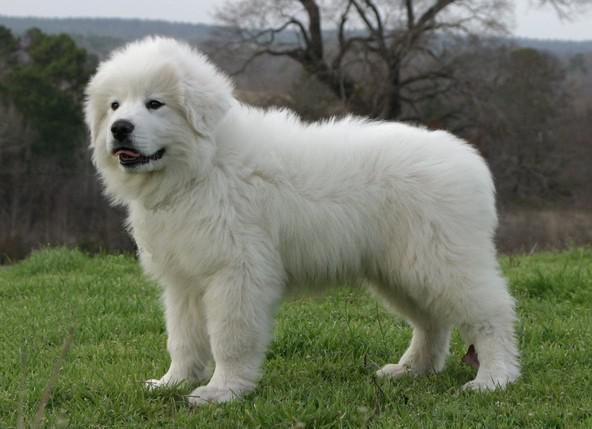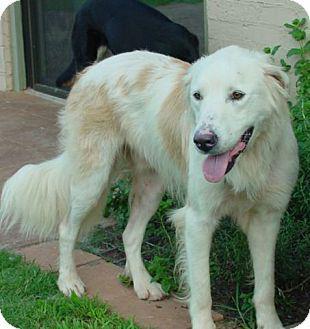The first image is the image on the left, the second image is the image on the right. Considering the images on both sides, is "The dog in the image on the right is lying in the grass outside." valid? Answer yes or no. No. 